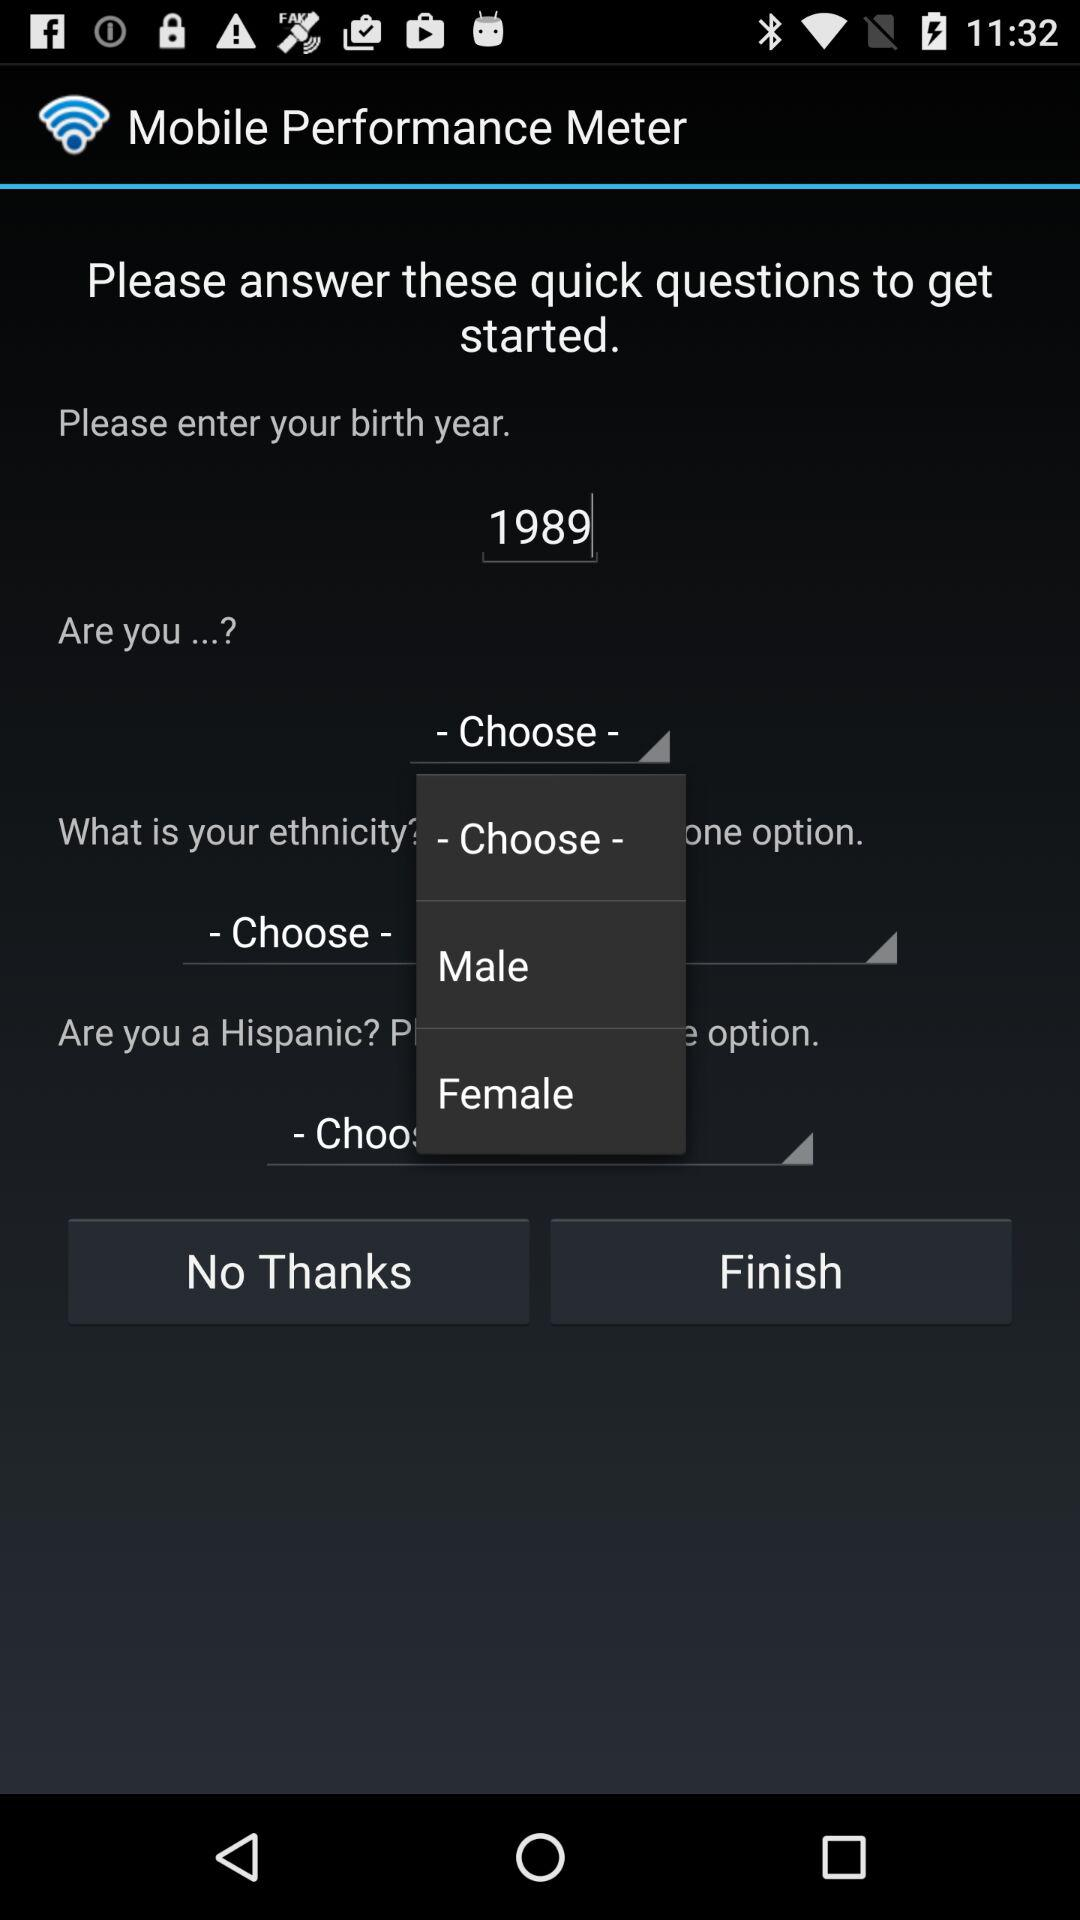What is the birth year? The birth year is 1989. 